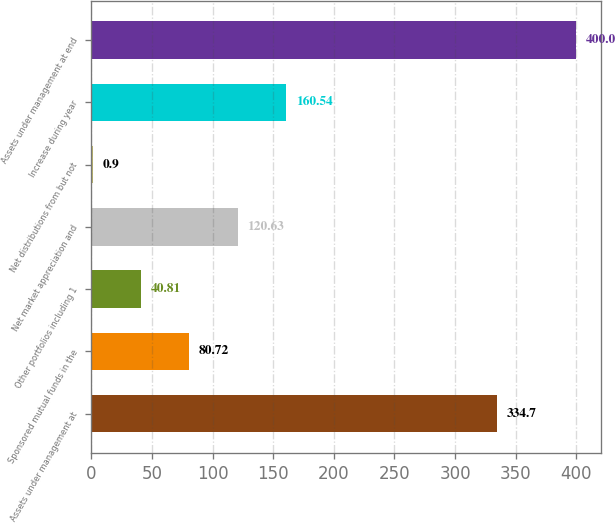<chart> <loc_0><loc_0><loc_500><loc_500><bar_chart><fcel>Assets under management at<fcel>Sponsored mutual funds in the<fcel>Other portfolios including 1<fcel>Net market appreciation and<fcel>Net distributions from but not<fcel>Increase during year<fcel>Assets under management at end<nl><fcel>334.7<fcel>80.72<fcel>40.81<fcel>120.63<fcel>0.9<fcel>160.54<fcel>400<nl></chart> 